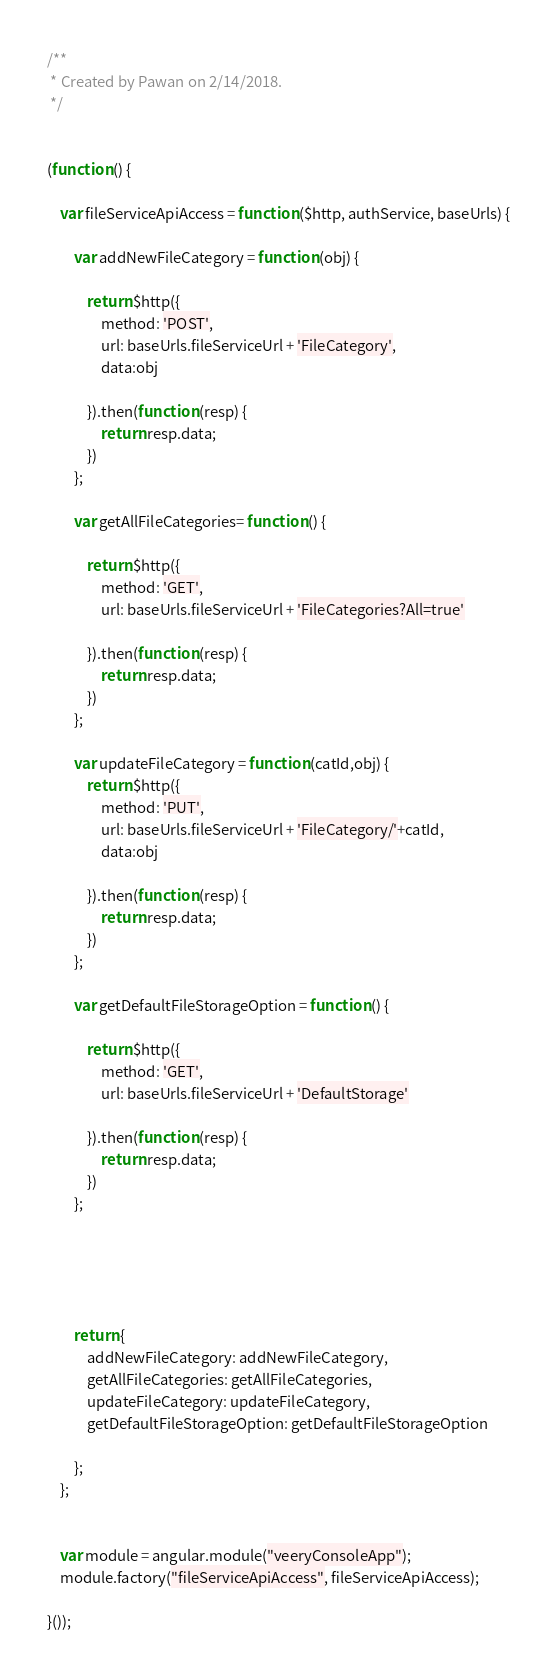Convert code to text. <code><loc_0><loc_0><loc_500><loc_500><_JavaScript_>/**
 * Created by Pawan on 2/14/2018.
 */


(function () {

    var fileServiceApiAccess = function ($http, authService, baseUrls) {

        var addNewFileCategory = function (obj) {

            return $http({
                method: 'POST',
                url: baseUrls.fileServiceUrl + 'FileCategory',
                data:obj

            }).then(function (resp) {
                return resp.data;
            })
        };

        var getAllFileCategories= function () {

            return $http({
                method: 'GET',
                url: baseUrls.fileServiceUrl + 'FileCategories?All=true'

            }).then(function (resp) {
                return resp.data;
            })
        };

        var updateFileCategory = function (catId,obj) {
            return $http({
                method: 'PUT',
                url: baseUrls.fileServiceUrl + 'FileCategory/'+catId,
                data:obj

            }).then(function (resp) {
                return resp.data;
            })
        };

        var getDefaultFileStorageOption = function () {

            return $http({
                method: 'GET',
                url: baseUrls.fileServiceUrl + 'DefaultStorage'

            }).then(function (resp) {
                return resp.data;
            })
        };





        return {
            addNewFileCategory: addNewFileCategory,
            getAllFileCategories: getAllFileCategories,
            updateFileCategory: updateFileCategory,
            getDefaultFileStorageOption: getDefaultFileStorageOption

        };
    };


    var module = angular.module("veeryConsoleApp");
    module.factory("fileServiceApiAccess", fileServiceApiAccess);

}());
</code> 